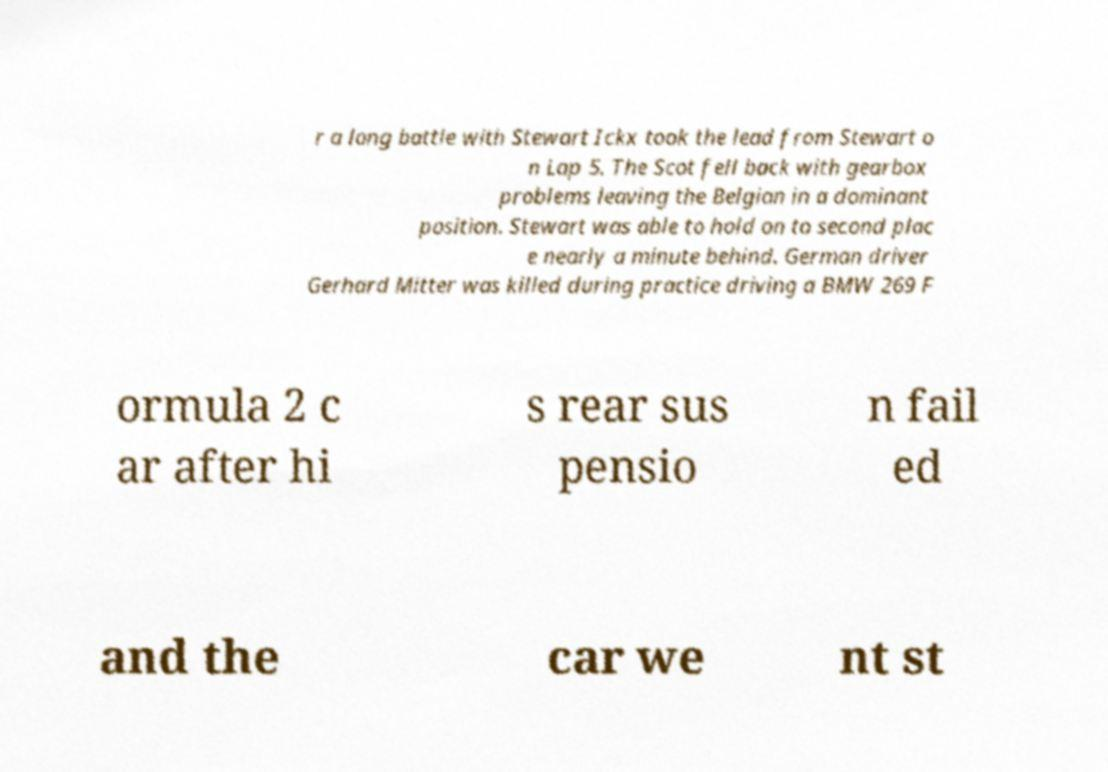Please identify and transcribe the text found in this image. r a long battle with Stewart Ickx took the lead from Stewart o n Lap 5. The Scot fell back with gearbox problems leaving the Belgian in a dominant position. Stewart was able to hold on to second plac e nearly a minute behind. German driver Gerhard Mitter was killed during practice driving a BMW 269 F ormula 2 c ar after hi s rear sus pensio n fail ed and the car we nt st 